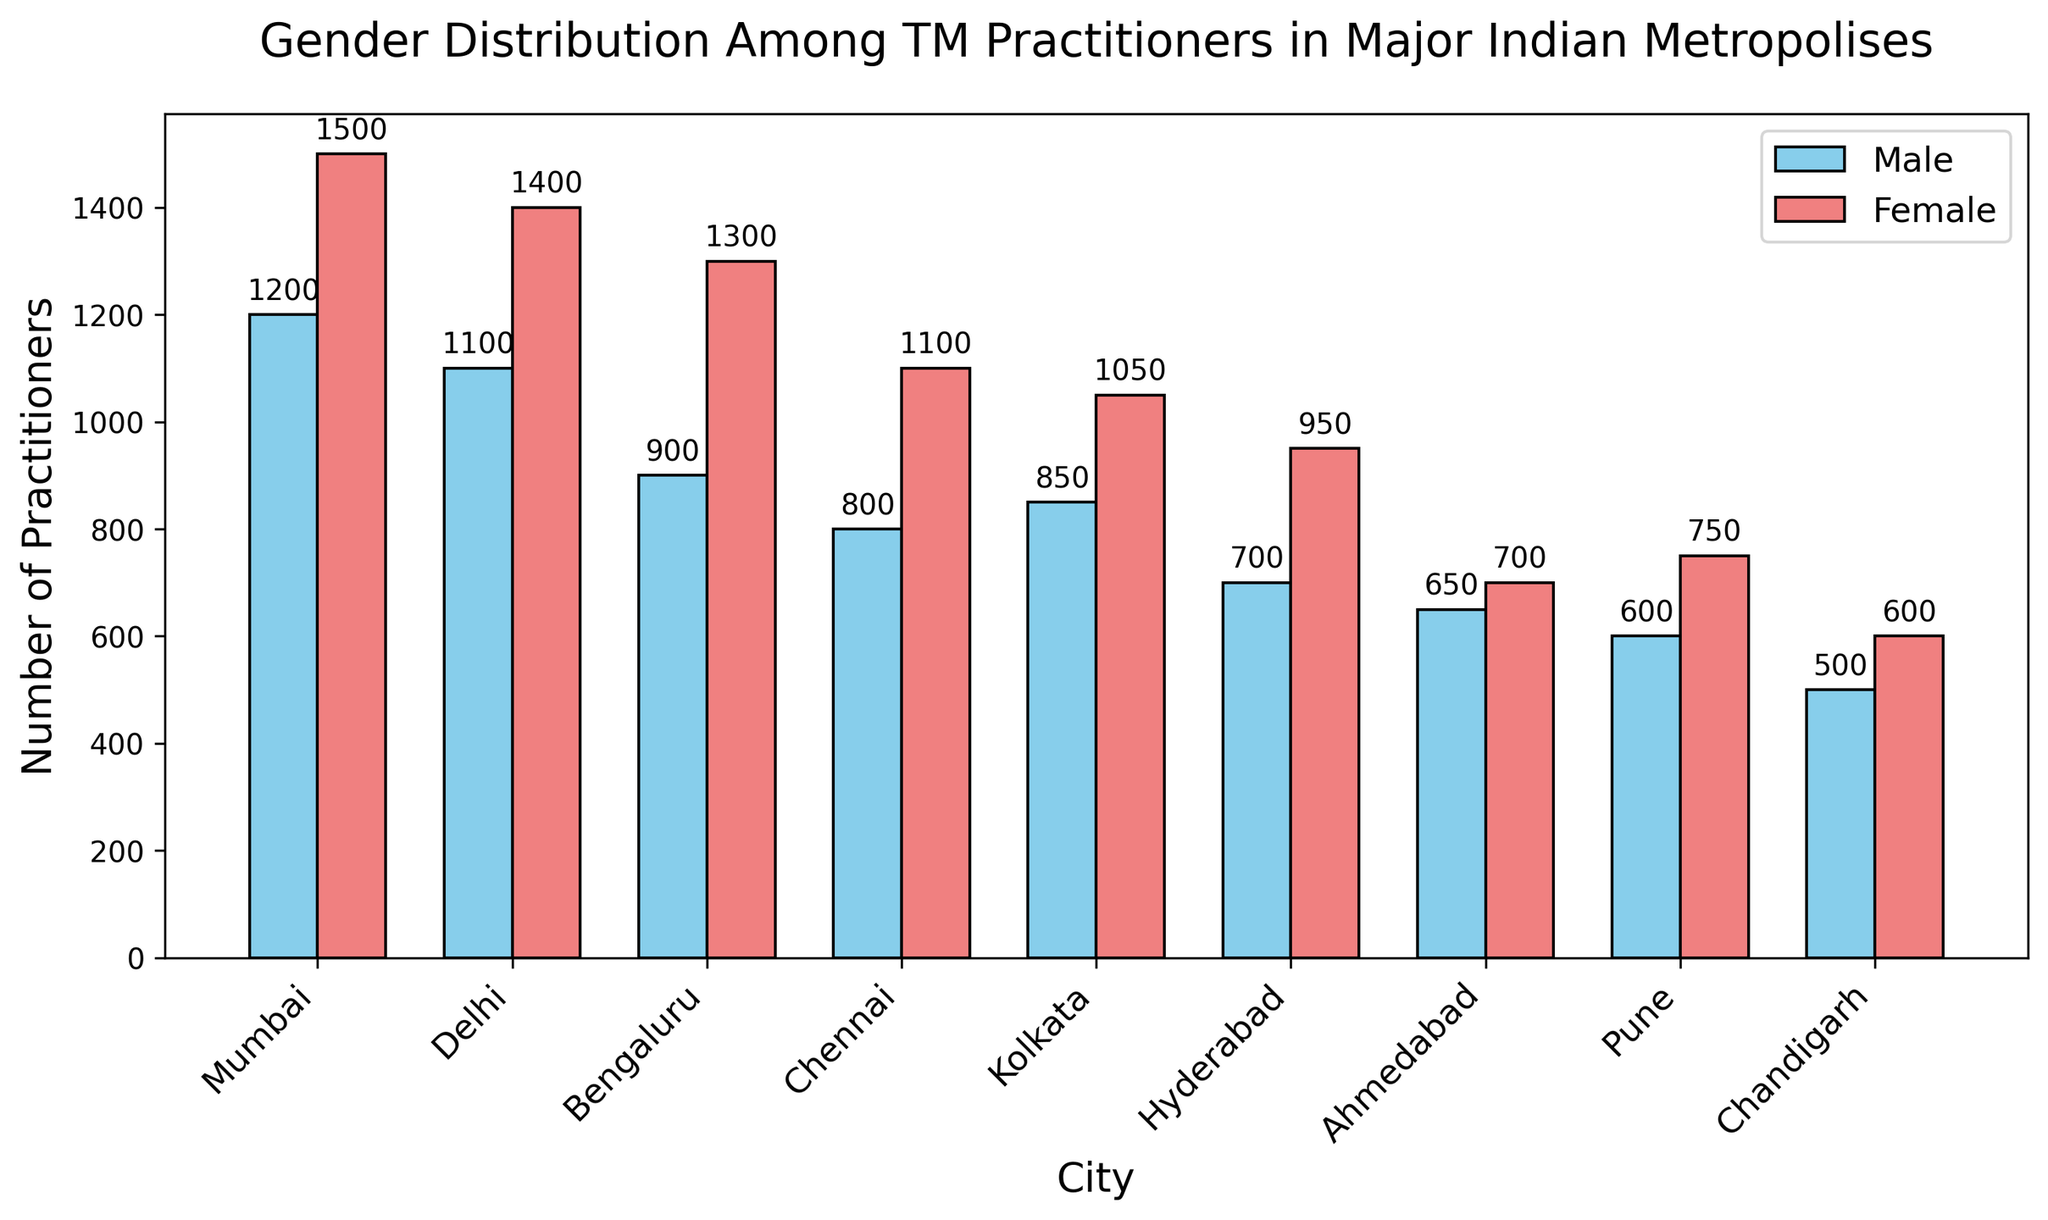Which city has the highest number of female TM practitioners? First, note the bars for female practitioners in each city. The bar for Mumbai stands out as the highest.
Answer: Mumbai Which gender has more practitioners overall in Hyderabad? Compare the height of the bars for male and female practitioners in Hyderabad. The bar for females is higher.
Answer: Female What is the total number of TM practitioners in Chennai? Add the counts of male and female practitioners in Chennai: 800 (male) + 1100 (female) = 1900.
Answer: 1900 How does the number of male practitioners in Bengaluru compare to that in Kolkata? Look at the heights of the bars for male practitioners in Bengaluru and Kolkata. Bengaluru has a higher count (900 vs. 850).
Answer: Bengaluru Which city has the smallest total number of TM practitioners? Sum the male and female counts for each city and compare. Chandigarh has the smallest total (500 male + 600 female = 1100).
Answer: Chandigarh What's the difference between the number of female practitioners in Pune and Chandigarh? Subtract the number of female practitioners in Chandigarh (600) from Pune (750): 750 - 600 = 150.
Answer: 150 In which city is the number of male practitioners closest to the number of female practitioners? Compare the differences in counts for each city. Ahmedabad has the smallest difference: 700 (female) - 650 (male) = 50.
Answer: Ahmedabad Which city has the highest combined number of practitioners (both male and female)? Calculate the combined number of practitioners for each city and compare. Mumbai has the highest combined number: 1200 (male) + 1500 (female) = 2700.
Answer: Mumbai What is the average number of female practitioners across all cities? Sum the female counts and divide by the number of cities: (1500 + 1400 + 1300 + 1100 + 1050 + 950 + 700 + 750 + 600) / 9 = 9350 / 9 = 1038.9
Answer: 1038.9 